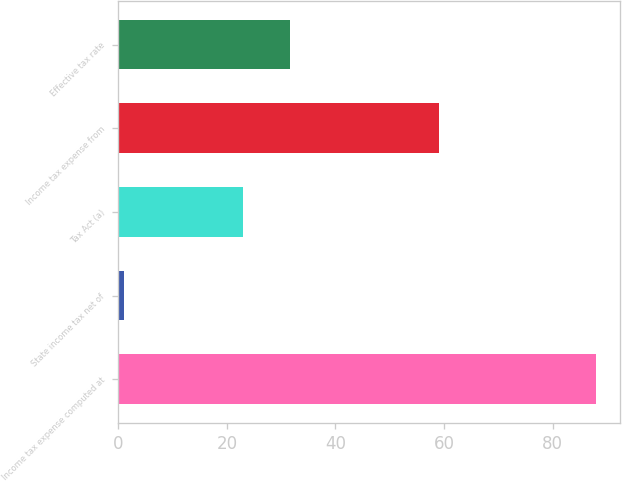Convert chart to OTSL. <chart><loc_0><loc_0><loc_500><loc_500><bar_chart><fcel>Income tax expense computed at<fcel>State income tax net of<fcel>Tax Act (a)<fcel>Income tax expense from<fcel>Effective tax rate<nl><fcel>88<fcel>1<fcel>23<fcel>59<fcel>31.7<nl></chart> 